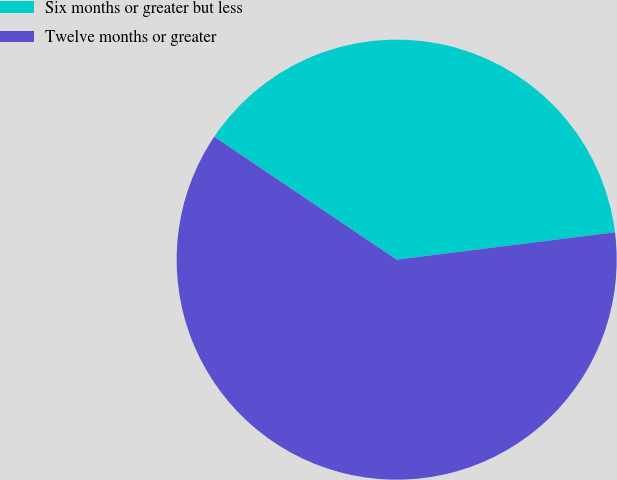Convert chart to OTSL. <chart><loc_0><loc_0><loc_500><loc_500><pie_chart><fcel>Six months or greater but less<fcel>Twelve months or greater<nl><fcel>38.58%<fcel>61.42%<nl></chart> 